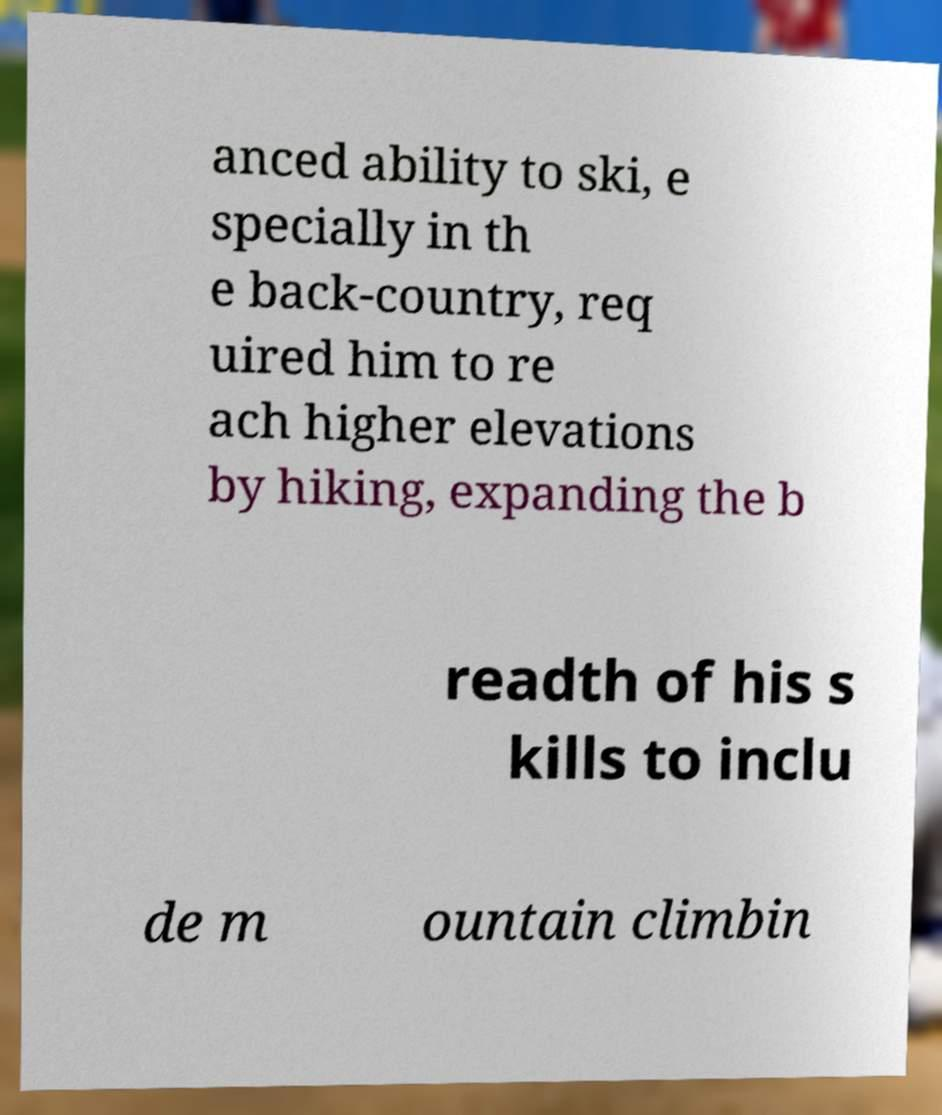For documentation purposes, I need the text within this image transcribed. Could you provide that? anced ability to ski, e specially in th e back-country, req uired him to re ach higher elevations by hiking, expanding the b readth of his s kills to inclu de m ountain climbin 